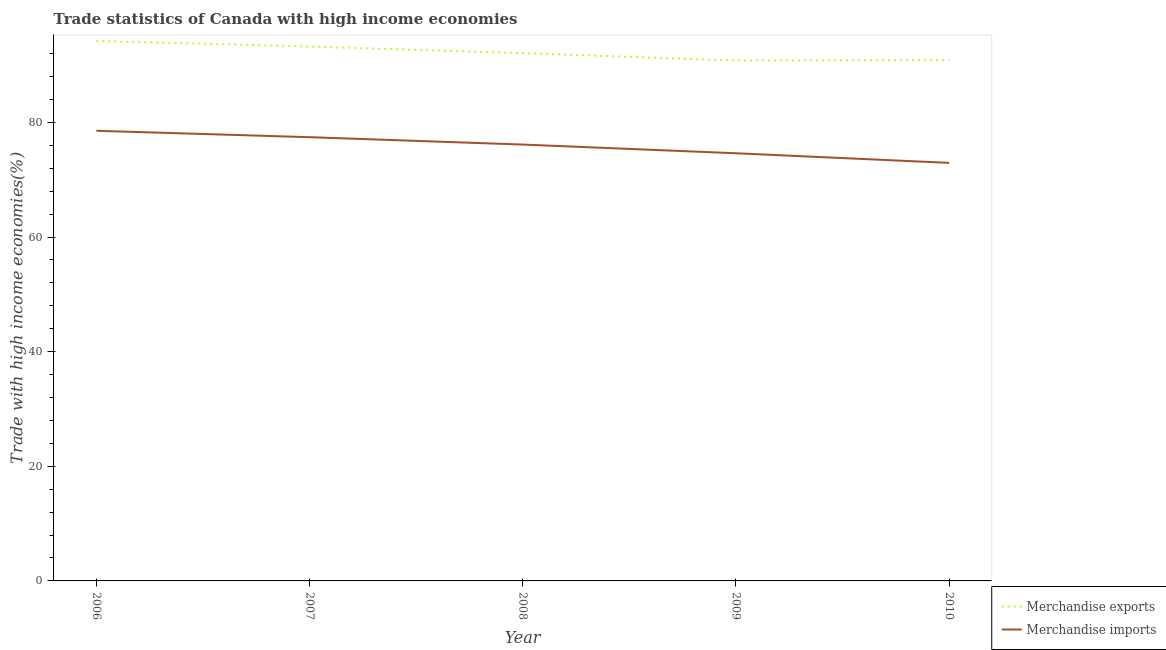How many different coloured lines are there?
Provide a short and direct response. 2. Is the number of lines equal to the number of legend labels?
Offer a terse response. Yes. What is the merchandise imports in 2010?
Provide a succinct answer. 72.95. Across all years, what is the maximum merchandise exports?
Your response must be concise. 94.22. Across all years, what is the minimum merchandise imports?
Make the answer very short. 72.95. In which year was the merchandise exports maximum?
Your response must be concise. 2006. What is the total merchandise imports in the graph?
Keep it short and to the point. 379.7. What is the difference between the merchandise imports in 2007 and that in 2010?
Your response must be concise. 4.48. What is the difference between the merchandise imports in 2010 and the merchandise exports in 2007?
Your response must be concise. -20.31. What is the average merchandise exports per year?
Provide a succinct answer. 92.25. In the year 2008, what is the difference between the merchandise exports and merchandise imports?
Your answer should be compact. 15.96. In how many years, is the merchandise imports greater than 40 %?
Give a very brief answer. 5. What is the ratio of the merchandise exports in 2009 to that in 2010?
Your answer should be very brief. 1. What is the difference between the highest and the second highest merchandise exports?
Give a very brief answer. 0.97. What is the difference between the highest and the lowest merchandise imports?
Offer a very short reply. 5.6. In how many years, is the merchandise imports greater than the average merchandise imports taken over all years?
Your answer should be compact. 3. Does the merchandise imports monotonically increase over the years?
Your answer should be very brief. No. Is the merchandise exports strictly greater than the merchandise imports over the years?
Make the answer very short. Yes. How many years are there in the graph?
Provide a short and direct response. 5. What is the difference between two consecutive major ticks on the Y-axis?
Provide a short and direct response. 20. Are the values on the major ticks of Y-axis written in scientific E-notation?
Your answer should be very brief. No. How many legend labels are there?
Offer a terse response. 2. What is the title of the graph?
Your response must be concise. Trade statistics of Canada with high income economies. Does "Tetanus" appear as one of the legend labels in the graph?
Make the answer very short. No. What is the label or title of the Y-axis?
Provide a succinct answer. Trade with high income economies(%). What is the Trade with high income economies(%) of Merchandise exports in 2006?
Offer a very short reply. 94.22. What is the Trade with high income economies(%) in Merchandise imports in 2006?
Ensure brevity in your answer.  78.55. What is the Trade with high income economies(%) in Merchandise exports in 2007?
Keep it short and to the point. 93.25. What is the Trade with high income economies(%) in Merchandise imports in 2007?
Offer a very short reply. 77.43. What is the Trade with high income economies(%) in Merchandise exports in 2008?
Give a very brief answer. 92.1. What is the Trade with high income economies(%) in Merchandise imports in 2008?
Provide a short and direct response. 76.14. What is the Trade with high income economies(%) of Merchandise exports in 2009?
Keep it short and to the point. 90.81. What is the Trade with high income economies(%) of Merchandise imports in 2009?
Your answer should be compact. 74.63. What is the Trade with high income economies(%) of Merchandise exports in 2010?
Your response must be concise. 90.86. What is the Trade with high income economies(%) of Merchandise imports in 2010?
Ensure brevity in your answer.  72.95. Across all years, what is the maximum Trade with high income economies(%) of Merchandise exports?
Keep it short and to the point. 94.22. Across all years, what is the maximum Trade with high income economies(%) of Merchandise imports?
Offer a very short reply. 78.55. Across all years, what is the minimum Trade with high income economies(%) in Merchandise exports?
Provide a succinct answer. 90.81. Across all years, what is the minimum Trade with high income economies(%) of Merchandise imports?
Your answer should be compact. 72.95. What is the total Trade with high income economies(%) of Merchandise exports in the graph?
Provide a short and direct response. 461.26. What is the total Trade with high income economies(%) in Merchandise imports in the graph?
Offer a terse response. 379.7. What is the difference between the Trade with high income economies(%) in Merchandise exports in 2006 and that in 2007?
Provide a succinct answer. 0.97. What is the difference between the Trade with high income economies(%) in Merchandise imports in 2006 and that in 2007?
Ensure brevity in your answer.  1.12. What is the difference between the Trade with high income economies(%) in Merchandise exports in 2006 and that in 2008?
Make the answer very short. 2.12. What is the difference between the Trade with high income economies(%) of Merchandise imports in 2006 and that in 2008?
Ensure brevity in your answer.  2.4. What is the difference between the Trade with high income economies(%) in Merchandise exports in 2006 and that in 2009?
Provide a succinct answer. 3.41. What is the difference between the Trade with high income economies(%) of Merchandise imports in 2006 and that in 2009?
Offer a terse response. 3.92. What is the difference between the Trade with high income economies(%) in Merchandise exports in 2006 and that in 2010?
Provide a short and direct response. 3.36. What is the difference between the Trade with high income economies(%) in Merchandise imports in 2006 and that in 2010?
Make the answer very short. 5.6. What is the difference between the Trade with high income economies(%) in Merchandise exports in 2007 and that in 2008?
Offer a terse response. 1.15. What is the difference between the Trade with high income economies(%) of Merchandise imports in 2007 and that in 2008?
Ensure brevity in your answer.  1.29. What is the difference between the Trade with high income economies(%) in Merchandise exports in 2007 and that in 2009?
Offer a very short reply. 2.44. What is the difference between the Trade with high income economies(%) of Merchandise imports in 2007 and that in 2009?
Offer a very short reply. 2.8. What is the difference between the Trade with high income economies(%) in Merchandise exports in 2007 and that in 2010?
Make the answer very short. 2.39. What is the difference between the Trade with high income economies(%) in Merchandise imports in 2007 and that in 2010?
Your response must be concise. 4.48. What is the difference between the Trade with high income economies(%) of Merchandise exports in 2008 and that in 2009?
Make the answer very short. 1.29. What is the difference between the Trade with high income economies(%) in Merchandise imports in 2008 and that in 2009?
Provide a short and direct response. 1.52. What is the difference between the Trade with high income economies(%) of Merchandise exports in 2008 and that in 2010?
Offer a terse response. 1.24. What is the difference between the Trade with high income economies(%) of Merchandise imports in 2008 and that in 2010?
Provide a short and direct response. 3.19. What is the difference between the Trade with high income economies(%) of Merchandise exports in 2009 and that in 2010?
Your response must be concise. -0.05. What is the difference between the Trade with high income economies(%) in Merchandise imports in 2009 and that in 2010?
Your answer should be compact. 1.68. What is the difference between the Trade with high income economies(%) in Merchandise exports in 2006 and the Trade with high income economies(%) in Merchandise imports in 2007?
Provide a succinct answer. 16.79. What is the difference between the Trade with high income economies(%) in Merchandise exports in 2006 and the Trade with high income economies(%) in Merchandise imports in 2008?
Make the answer very short. 18.08. What is the difference between the Trade with high income economies(%) in Merchandise exports in 2006 and the Trade with high income economies(%) in Merchandise imports in 2009?
Your answer should be very brief. 19.59. What is the difference between the Trade with high income economies(%) in Merchandise exports in 2006 and the Trade with high income economies(%) in Merchandise imports in 2010?
Provide a short and direct response. 21.27. What is the difference between the Trade with high income economies(%) in Merchandise exports in 2007 and the Trade with high income economies(%) in Merchandise imports in 2008?
Provide a succinct answer. 17.11. What is the difference between the Trade with high income economies(%) in Merchandise exports in 2007 and the Trade with high income economies(%) in Merchandise imports in 2009?
Offer a terse response. 18.63. What is the difference between the Trade with high income economies(%) of Merchandise exports in 2007 and the Trade with high income economies(%) of Merchandise imports in 2010?
Your answer should be compact. 20.31. What is the difference between the Trade with high income economies(%) of Merchandise exports in 2008 and the Trade with high income economies(%) of Merchandise imports in 2009?
Provide a short and direct response. 17.48. What is the difference between the Trade with high income economies(%) in Merchandise exports in 2008 and the Trade with high income economies(%) in Merchandise imports in 2010?
Your answer should be very brief. 19.15. What is the difference between the Trade with high income economies(%) of Merchandise exports in 2009 and the Trade with high income economies(%) of Merchandise imports in 2010?
Offer a terse response. 17.87. What is the average Trade with high income economies(%) in Merchandise exports per year?
Offer a very short reply. 92.25. What is the average Trade with high income economies(%) of Merchandise imports per year?
Give a very brief answer. 75.94. In the year 2006, what is the difference between the Trade with high income economies(%) in Merchandise exports and Trade with high income economies(%) in Merchandise imports?
Provide a succinct answer. 15.67. In the year 2007, what is the difference between the Trade with high income economies(%) in Merchandise exports and Trade with high income economies(%) in Merchandise imports?
Your answer should be very brief. 15.82. In the year 2008, what is the difference between the Trade with high income economies(%) in Merchandise exports and Trade with high income economies(%) in Merchandise imports?
Your answer should be compact. 15.96. In the year 2009, what is the difference between the Trade with high income economies(%) of Merchandise exports and Trade with high income economies(%) of Merchandise imports?
Make the answer very short. 16.19. In the year 2010, what is the difference between the Trade with high income economies(%) of Merchandise exports and Trade with high income economies(%) of Merchandise imports?
Your response must be concise. 17.92. What is the ratio of the Trade with high income economies(%) of Merchandise exports in 2006 to that in 2007?
Ensure brevity in your answer.  1.01. What is the ratio of the Trade with high income economies(%) in Merchandise imports in 2006 to that in 2007?
Provide a short and direct response. 1.01. What is the ratio of the Trade with high income economies(%) in Merchandise exports in 2006 to that in 2008?
Offer a very short reply. 1.02. What is the ratio of the Trade with high income economies(%) of Merchandise imports in 2006 to that in 2008?
Your response must be concise. 1.03. What is the ratio of the Trade with high income economies(%) in Merchandise exports in 2006 to that in 2009?
Your answer should be very brief. 1.04. What is the ratio of the Trade with high income economies(%) in Merchandise imports in 2006 to that in 2009?
Offer a terse response. 1.05. What is the ratio of the Trade with high income economies(%) of Merchandise exports in 2006 to that in 2010?
Your answer should be compact. 1.04. What is the ratio of the Trade with high income economies(%) of Merchandise imports in 2006 to that in 2010?
Your answer should be very brief. 1.08. What is the ratio of the Trade with high income economies(%) in Merchandise exports in 2007 to that in 2008?
Ensure brevity in your answer.  1.01. What is the ratio of the Trade with high income economies(%) in Merchandise imports in 2007 to that in 2008?
Provide a succinct answer. 1.02. What is the ratio of the Trade with high income economies(%) in Merchandise exports in 2007 to that in 2009?
Provide a succinct answer. 1.03. What is the ratio of the Trade with high income economies(%) in Merchandise imports in 2007 to that in 2009?
Offer a very short reply. 1.04. What is the ratio of the Trade with high income economies(%) of Merchandise exports in 2007 to that in 2010?
Provide a succinct answer. 1.03. What is the ratio of the Trade with high income economies(%) of Merchandise imports in 2007 to that in 2010?
Provide a succinct answer. 1.06. What is the ratio of the Trade with high income economies(%) of Merchandise exports in 2008 to that in 2009?
Provide a short and direct response. 1.01. What is the ratio of the Trade with high income economies(%) in Merchandise imports in 2008 to that in 2009?
Make the answer very short. 1.02. What is the ratio of the Trade with high income economies(%) in Merchandise exports in 2008 to that in 2010?
Your answer should be compact. 1.01. What is the ratio of the Trade with high income economies(%) of Merchandise imports in 2008 to that in 2010?
Your response must be concise. 1.04. What is the ratio of the Trade with high income economies(%) in Merchandise imports in 2009 to that in 2010?
Ensure brevity in your answer.  1.02. What is the difference between the highest and the second highest Trade with high income economies(%) of Merchandise exports?
Offer a very short reply. 0.97. What is the difference between the highest and the second highest Trade with high income economies(%) of Merchandise imports?
Your answer should be very brief. 1.12. What is the difference between the highest and the lowest Trade with high income economies(%) in Merchandise exports?
Your response must be concise. 3.41. What is the difference between the highest and the lowest Trade with high income economies(%) in Merchandise imports?
Your answer should be compact. 5.6. 